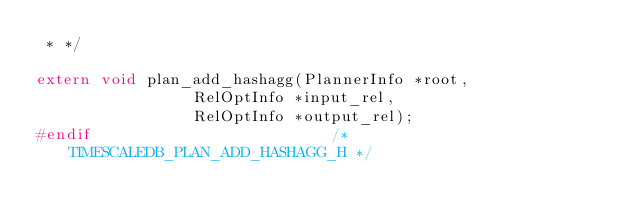Convert code to text. <code><loc_0><loc_0><loc_500><loc_500><_C_> * */

extern void plan_add_hashagg(PlannerInfo *root,
				 RelOptInfo *input_rel,
				 RelOptInfo *output_rel);
#endif							/* TIMESCALEDB_PLAN_ADD_HASHAGG_H */
</code> 